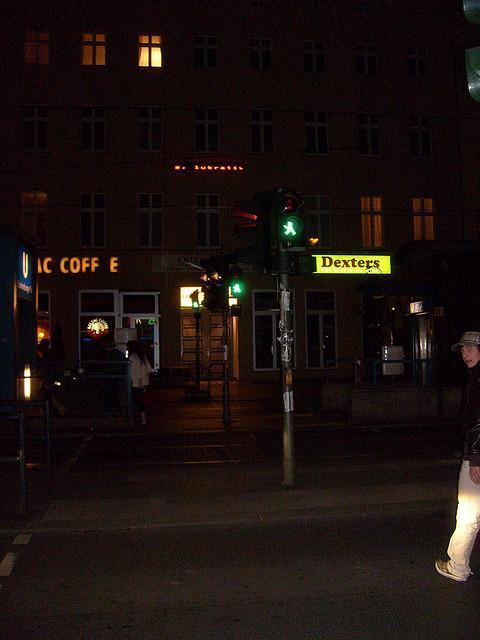How many people are in the picture?
Give a very brief answer. 2. 